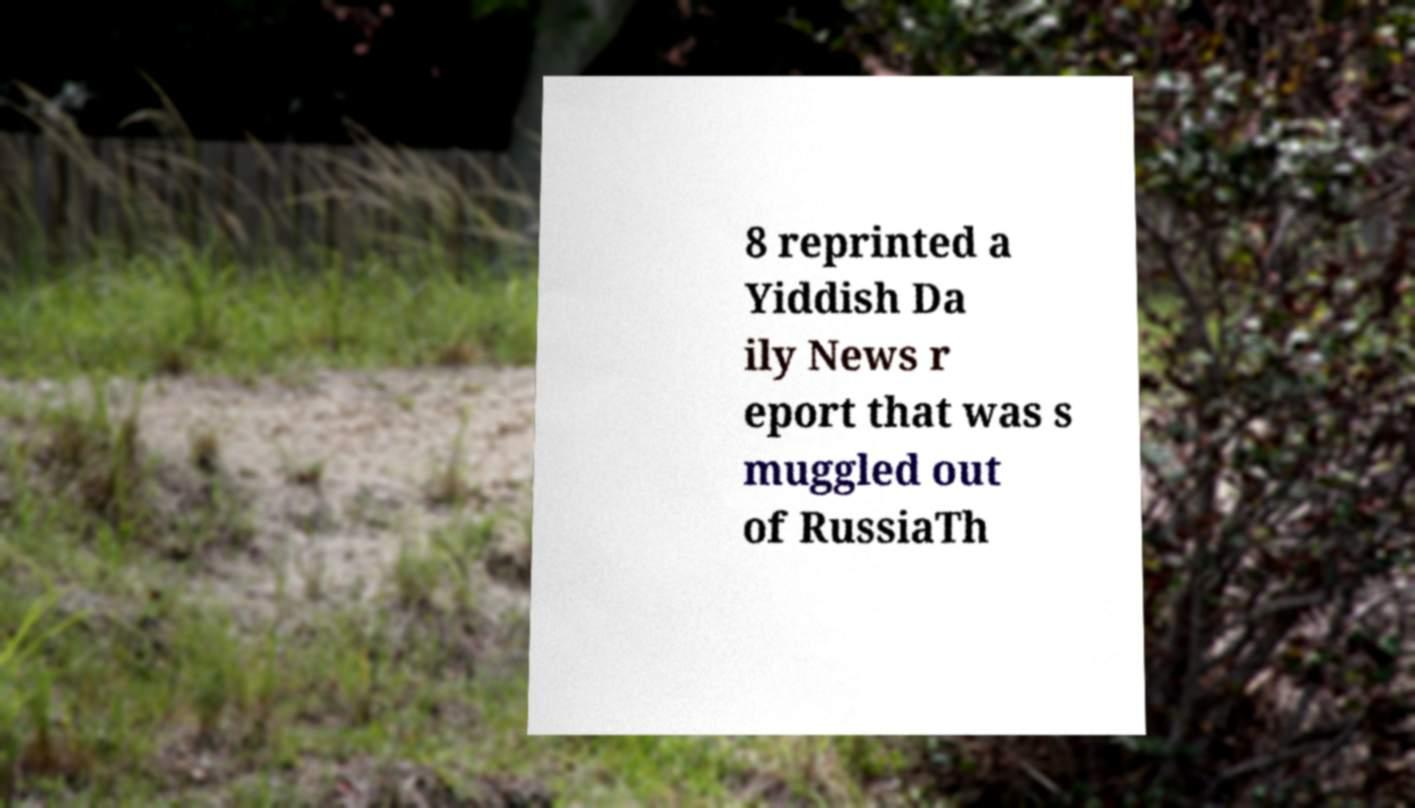Could you extract and type out the text from this image? 8 reprinted a Yiddish Da ily News r eport that was s muggled out of RussiaTh 